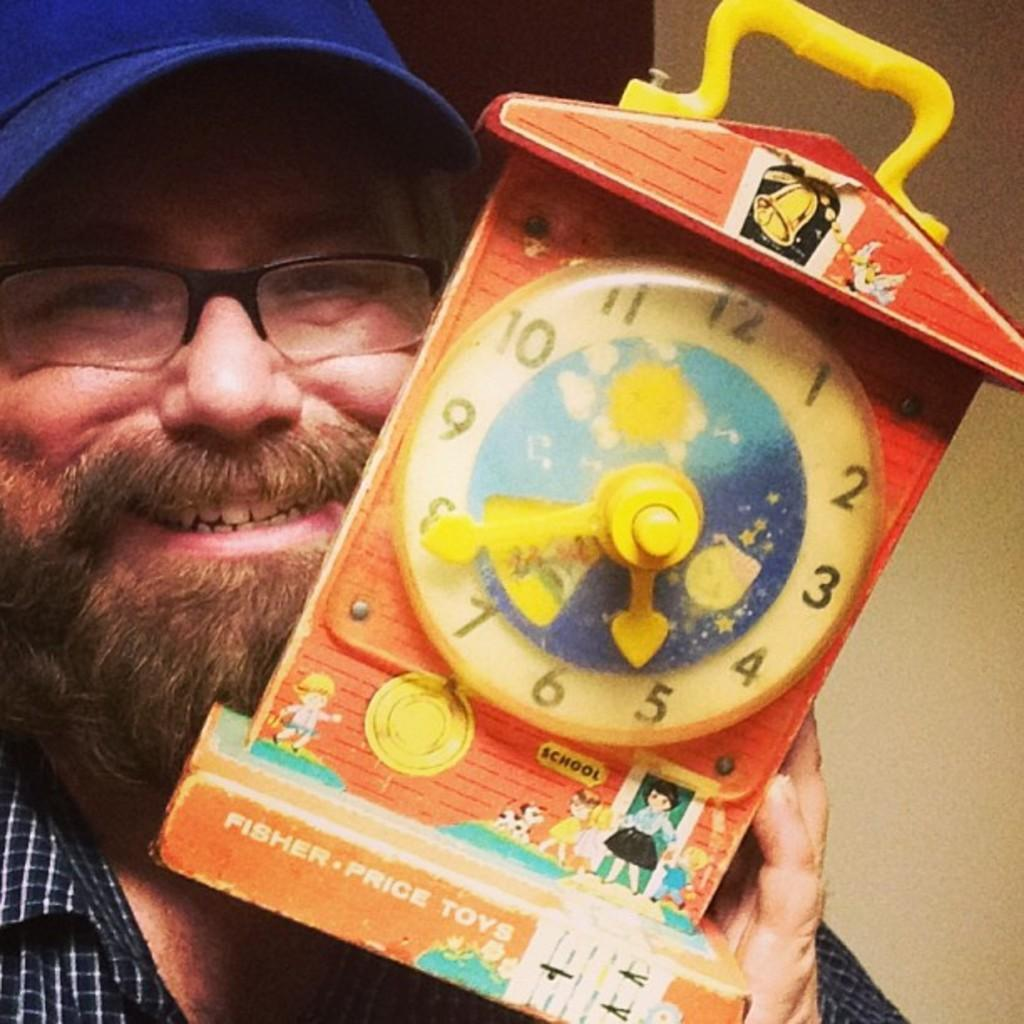Who is present in the image? There is a man in the image. What is the man holding in the image? The man is holding a toy clock. What type of clothing is the man wearing? The man is wearing a shirt. Are there any accessories visible on the man? Yes, the man is wearing spectacles and a cap. What type of soda does the man prefer in the image? There is no information about the man's soda preference in the image. 